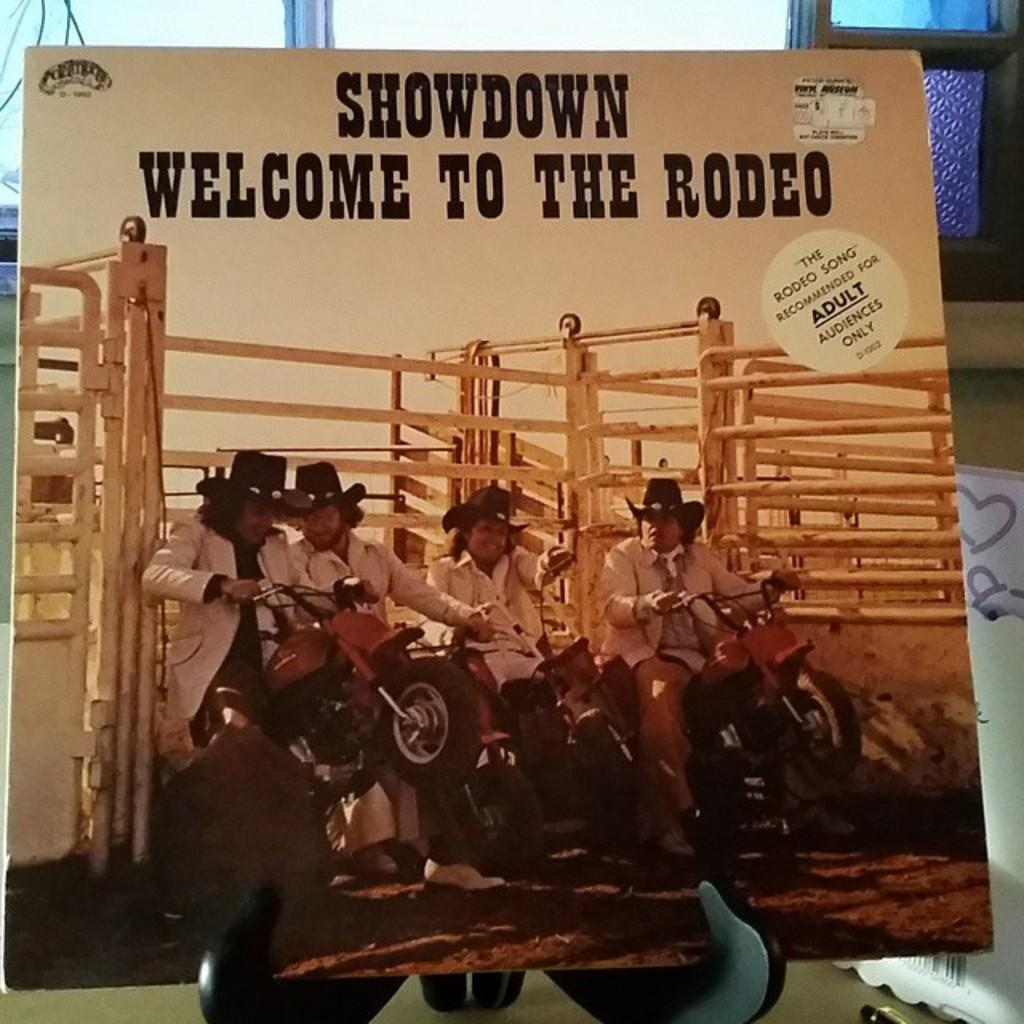What are the persons in the image doing? The persons in the image are sitting on a bike. What can be seen behind the persons? There is a white fence behind them. Is there any text or writing visible in the image? Yes, there is something written above the fence. What type of linen is being used to cover the hospital bed in the image? There is no hospital bed or linen present in the image; it features persons sitting on a bike with a white fence in the background. Can you tell me how many trucks are visible in the image? There are no trucks present in the image. 